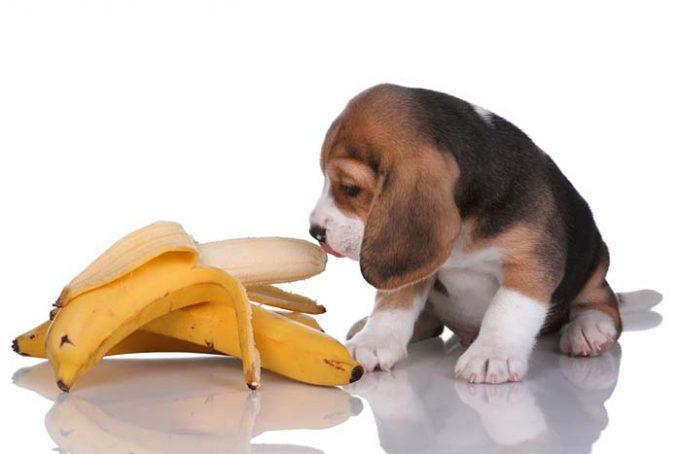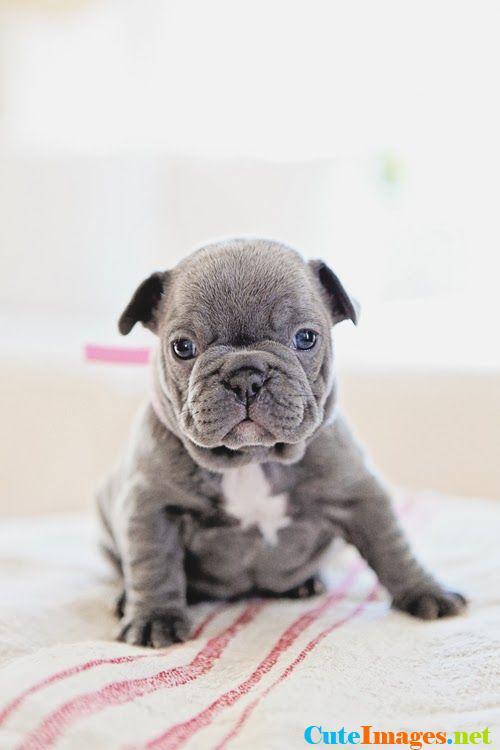The first image is the image on the left, the second image is the image on the right. Evaluate the accuracy of this statement regarding the images: "One image shows a dog with its face near a peeled banana shape.". Is it true? Answer yes or no. Yes. The first image is the image on the left, the second image is the image on the right. Analyze the images presented: Is the assertion "One image features a dog next to a half-peeled banana." valid? Answer yes or no. Yes. 